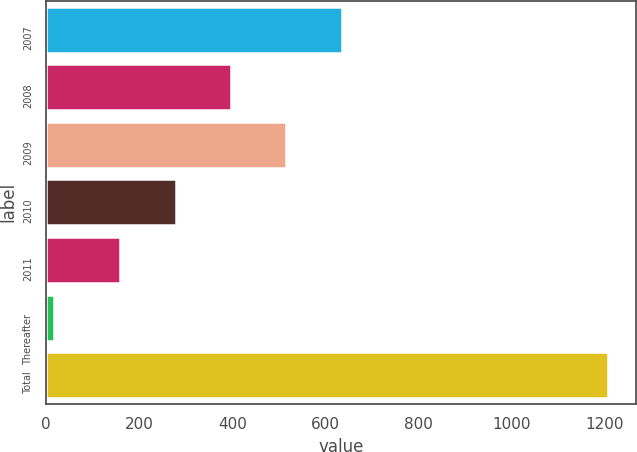Convert chart to OTSL. <chart><loc_0><loc_0><loc_500><loc_500><bar_chart><fcel>2007<fcel>2008<fcel>2009<fcel>2010<fcel>2011<fcel>Thereafter<fcel>Total<nl><fcel>635.4<fcel>397.2<fcel>516.3<fcel>278.1<fcel>159<fcel>16<fcel>1207<nl></chart> 